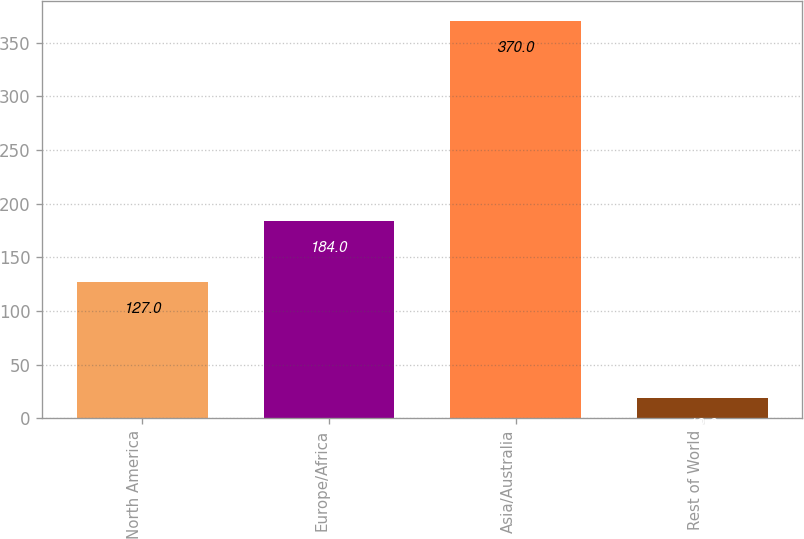Convert chart. <chart><loc_0><loc_0><loc_500><loc_500><bar_chart><fcel>North America<fcel>Europe/Africa<fcel>Asia/Australia<fcel>Rest of World<nl><fcel>127<fcel>184<fcel>370<fcel>19<nl></chart> 